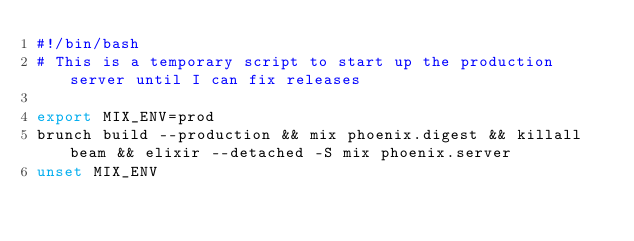<code> <loc_0><loc_0><loc_500><loc_500><_Bash_>#!/bin/bash
# This is a temporary script to start up the production server until I can fix releases

export MIX_ENV=prod
brunch build --production && mix phoenix.digest && killall beam && elixir --detached -S mix phoenix.server
unset MIX_ENV
</code> 